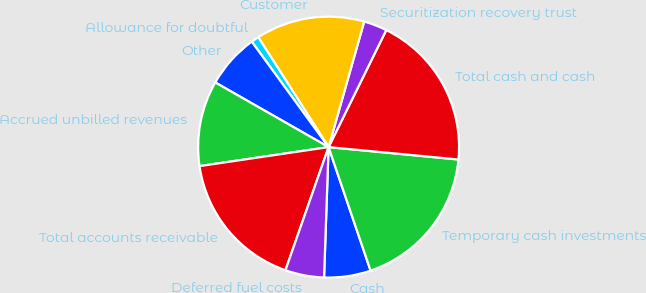Convert chart to OTSL. <chart><loc_0><loc_0><loc_500><loc_500><pie_chart><fcel>Cash<fcel>Temporary cash investments<fcel>Total cash and cash<fcel>Securitization recovery trust<fcel>Customer<fcel>Allowance for doubtful<fcel>Other<fcel>Accrued unbilled revenues<fcel>Total accounts receivable<fcel>Deferred fuel costs<nl><fcel>5.77%<fcel>18.27%<fcel>19.23%<fcel>2.89%<fcel>13.46%<fcel>0.96%<fcel>6.73%<fcel>10.58%<fcel>17.31%<fcel>4.81%<nl></chart> 